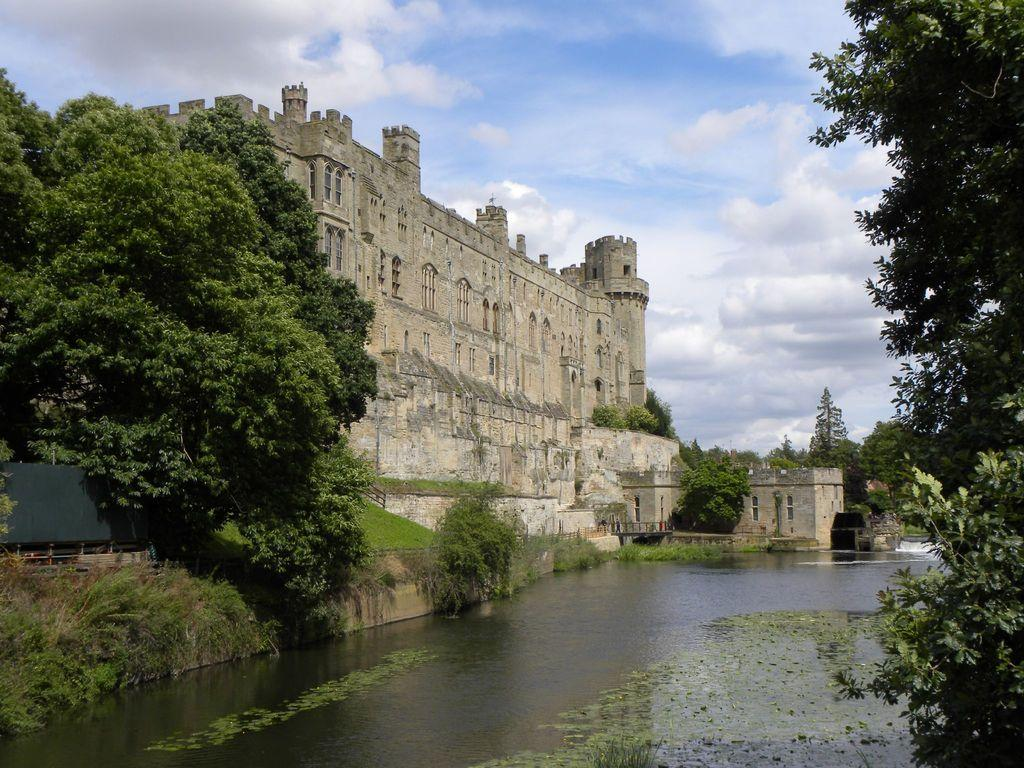What type of structure is present in the image? There is a building with windows in the image. What other natural elements can be seen in the image? There are plants, grass, and a group of trees in the image. Is there any water visible in the image? Yes, there is water visible in the image. How would you describe the sky in the image? The sky is visible in the image and appears cloudy. Can you tell me the belief system of the person standing near the building in the image? There is no person standing near the building in the image, so it is not possible to determine their belief system. 